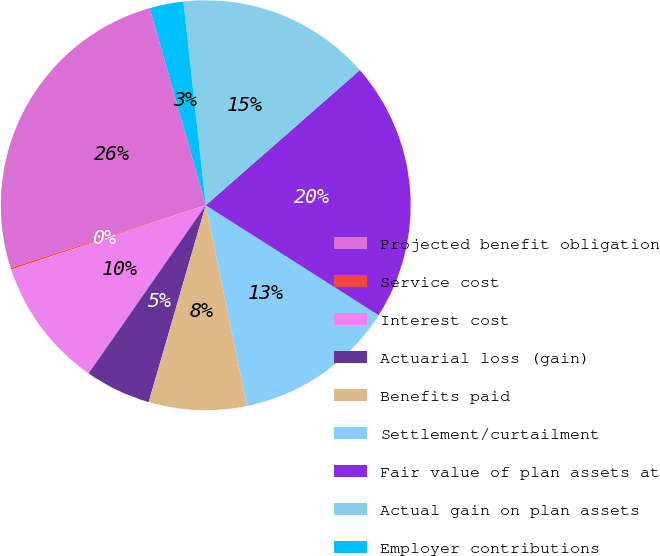<chart> <loc_0><loc_0><loc_500><loc_500><pie_chart><fcel>Projected benefit obligation<fcel>Service cost<fcel>Interest cost<fcel>Actuarial loss (gain)<fcel>Benefits paid<fcel>Settlement/curtailment<fcel>Fair value of plan assets at<fcel>Actual gain on plan assets<fcel>Employer contributions<nl><fcel>25.53%<fcel>0.14%<fcel>10.24%<fcel>5.19%<fcel>7.71%<fcel>12.76%<fcel>20.48%<fcel>15.28%<fcel>2.67%<nl></chart> 